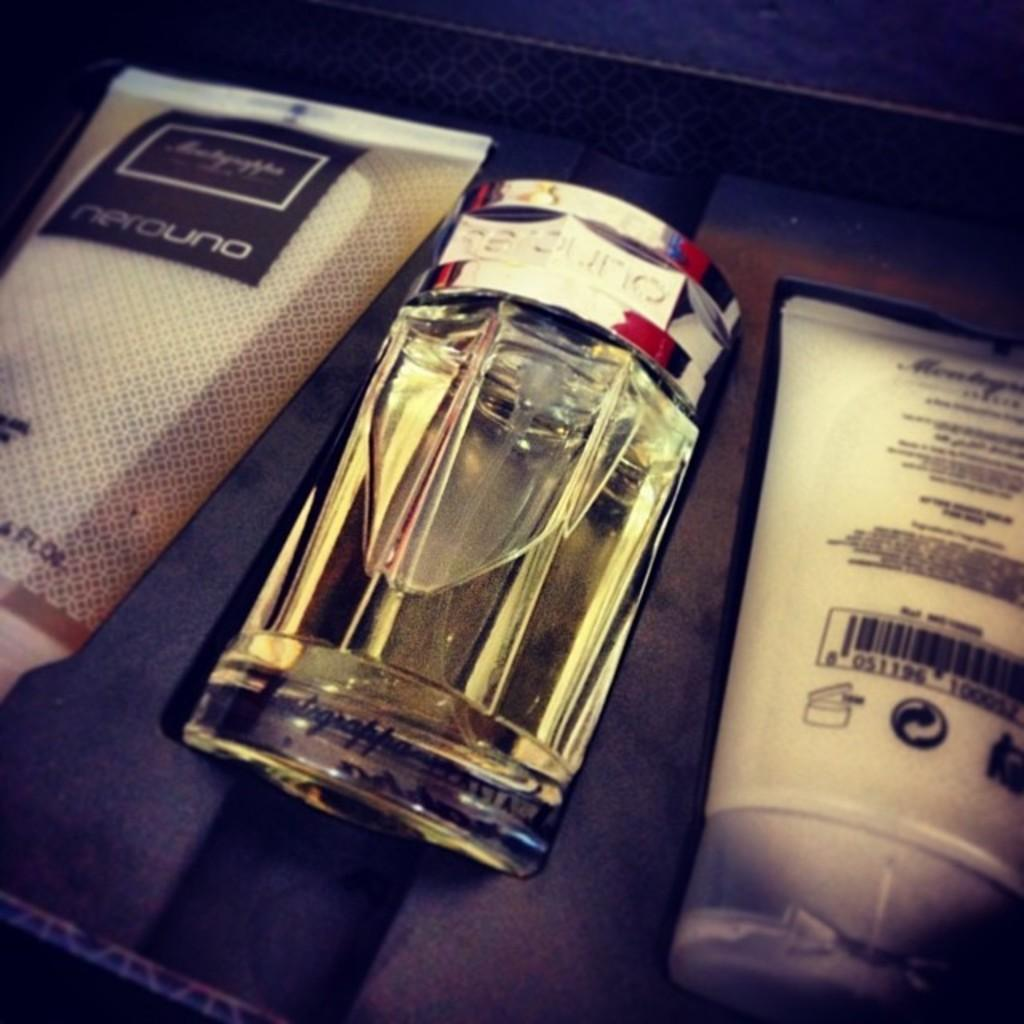<image>
Write a terse but informative summary of the picture. 3 containers of Nerouno brand products in a case. 